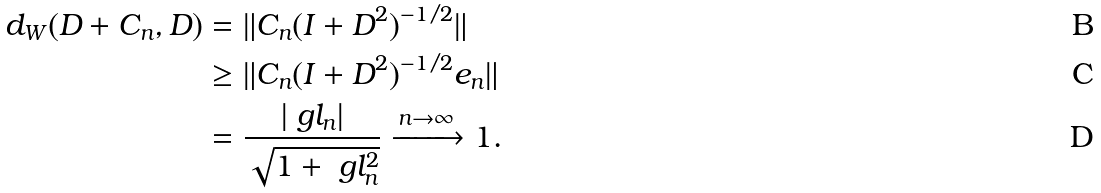<formula> <loc_0><loc_0><loc_500><loc_500>d _ { W } ( D + C _ { n } , D ) & = \| C _ { n } ( I + D ^ { 2 } ) ^ { - 1 / 2 } \| \\ & \geq \| C _ { n } ( I + D ^ { 2 } ) ^ { - 1 / 2 } e _ { n } \| \\ & = \frac { | \ g l _ { n } | } { \sqrt { 1 + \ g l _ { n } ^ { 2 } } } \xrightarrow { n \to \infty } 1 .</formula> 